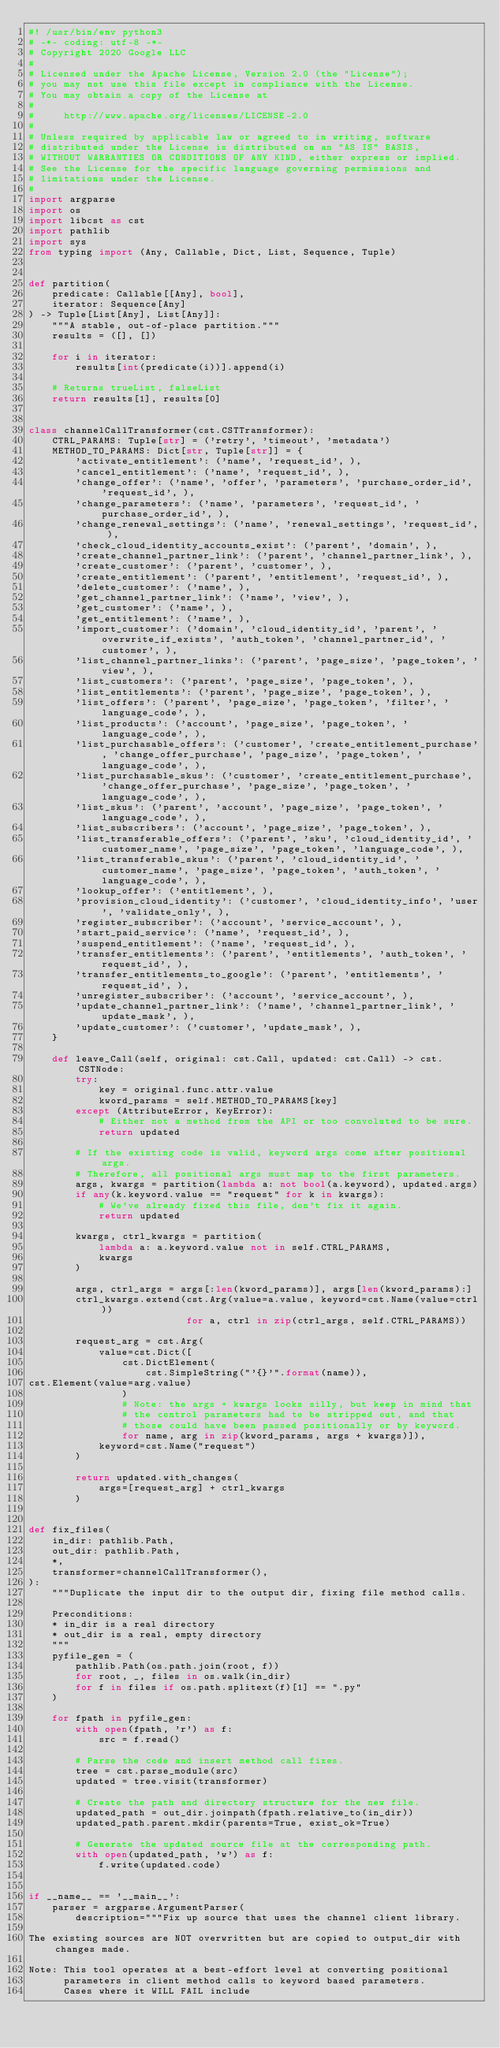<code> <loc_0><loc_0><loc_500><loc_500><_Python_>#! /usr/bin/env python3
# -*- coding: utf-8 -*-
# Copyright 2020 Google LLC
#
# Licensed under the Apache License, Version 2.0 (the "License");
# you may not use this file except in compliance with the License.
# You may obtain a copy of the License at
#
#     http://www.apache.org/licenses/LICENSE-2.0
#
# Unless required by applicable law or agreed to in writing, software
# distributed under the License is distributed on an "AS IS" BASIS,
# WITHOUT WARRANTIES OR CONDITIONS OF ANY KIND, either express or implied.
# See the License for the specific language governing permissions and
# limitations under the License.
#
import argparse
import os
import libcst as cst
import pathlib
import sys
from typing import (Any, Callable, Dict, List, Sequence, Tuple)


def partition(
    predicate: Callable[[Any], bool],
    iterator: Sequence[Any]
) -> Tuple[List[Any], List[Any]]:
    """A stable, out-of-place partition."""
    results = ([], [])

    for i in iterator:
        results[int(predicate(i))].append(i)

    # Returns trueList, falseList
    return results[1], results[0]


class channelCallTransformer(cst.CSTTransformer):
    CTRL_PARAMS: Tuple[str] = ('retry', 'timeout', 'metadata')
    METHOD_TO_PARAMS: Dict[str, Tuple[str]] = {
        'activate_entitlement': ('name', 'request_id', ),
        'cancel_entitlement': ('name', 'request_id', ),
        'change_offer': ('name', 'offer', 'parameters', 'purchase_order_id', 'request_id', ),
        'change_parameters': ('name', 'parameters', 'request_id', 'purchase_order_id', ),
        'change_renewal_settings': ('name', 'renewal_settings', 'request_id', ),
        'check_cloud_identity_accounts_exist': ('parent', 'domain', ),
        'create_channel_partner_link': ('parent', 'channel_partner_link', ),
        'create_customer': ('parent', 'customer', ),
        'create_entitlement': ('parent', 'entitlement', 'request_id', ),
        'delete_customer': ('name', ),
        'get_channel_partner_link': ('name', 'view', ),
        'get_customer': ('name', ),
        'get_entitlement': ('name', ),
        'import_customer': ('domain', 'cloud_identity_id', 'parent', 'overwrite_if_exists', 'auth_token', 'channel_partner_id', 'customer', ),
        'list_channel_partner_links': ('parent', 'page_size', 'page_token', 'view', ),
        'list_customers': ('parent', 'page_size', 'page_token', ),
        'list_entitlements': ('parent', 'page_size', 'page_token', ),
        'list_offers': ('parent', 'page_size', 'page_token', 'filter', 'language_code', ),
        'list_products': ('account', 'page_size', 'page_token', 'language_code', ),
        'list_purchasable_offers': ('customer', 'create_entitlement_purchase', 'change_offer_purchase', 'page_size', 'page_token', 'language_code', ),
        'list_purchasable_skus': ('customer', 'create_entitlement_purchase', 'change_offer_purchase', 'page_size', 'page_token', 'language_code', ),
        'list_skus': ('parent', 'account', 'page_size', 'page_token', 'language_code', ),
        'list_subscribers': ('account', 'page_size', 'page_token', ),
        'list_transferable_offers': ('parent', 'sku', 'cloud_identity_id', 'customer_name', 'page_size', 'page_token', 'language_code', ),
        'list_transferable_skus': ('parent', 'cloud_identity_id', 'customer_name', 'page_size', 'page_token', 'auth_token', 'language_code', ),
        'lookup_offer': ('entitlement', ),
        'provision_cloud_identity': ('customer', 'cloud_identity_info', 'user', 'validate_only', ),
        'register_subscriber': ('account', 'service_account', ),
        'start_paid_service': ('name', 'request_id', ),
        'suspend_entitlement': ('name', 'request_id', ),
        'transfer_entitlements': ('parent', 'entitlements', 'auth_token', 'request_id', ),
        'transfer_entitlements_to_google': ('parent', 'entitlements', 'request_id', ),
        'unregister_subscriber': ('account', 'service_account', ),
        'update_channel_partner_link': ('name', 'channel_partner_link', 'update_mask', ),
        'update_customer': ('customer', 'update_mask', ),
    }

    def leave_Call(self, original: cst.Call, updated: cst.Call) -> cst.CSTNode:
        try:
            key = original.func.attr.value
            kword_params = self.METHOD_TO_PARAMS[key]
        except (AttributeError, KeyError):
            # Either not a method from the API or too convoluted to be sure.
            return updated

        # If the existing code is valid, keyword args come after positional args.
        # Therefore, all positional args must map to the first parameters.
        args, kwargs = partition(lambda a: not bool(a.keyword), updated.args)
        if any(k.keyword.value == "request" for k in kwargs):
            # We've already fixed this file, don't fix it again.
            return updated

        kwargs, ctrl_kwargs = partition(
            lambda a: a.keyword.value not in self.CTRL_PARAMS,
            kwargs
        )

        args, ctrl_args = args[:len(kword_params)], args[len(kword_params):]
        ctrl_kwargs.extend(cst.Arg(value=a.value, keyword=cst.Name(value=ctrl))
                           for a, ctrl in zip(ctrl_args, self.CTRL_PARAMS))

        request_arg = cst.Arg(
            value=cst.Dict([
                cst.DictElement(
                    cst.SimpleString("'{}'".format(name)),
cst.Element(value=arg.value)
                )
                # Note: the args + kwargs looks silly, but keep in mind that
                # the control parameters had to be stripped out, and that
                # those could have been passed positionally or by keyword.
                for name, arg in zip(kword_params, args + kwargs)]),
            keyword=cst.Name("request")
        )

        return updated.with_changes(
            args=[request_arg] + ctrl_kwargs
        )


def fix_files(
    in_dir: pathlib.Path,
    out_dir: pathlib.Path,
    *,
    transformer=channelCallTransformer(),
):
    """Duplicate the input dir to the output dir, fixing file method calls.

    Preconditions:
    * in_dir is a real directory
    * out_dir is a real, empty directory
    """
    pyfile_gen = (
        pathlib.Path(os.path.join(root, f))
        for root, _, files in os.walk(in_dir)
        for f in files if os.path.splitext(f)[1] == ".py"
    )

    for fpath in pyfile_gen:
        with open(fpath, 'r') as f:
            src = f.read()

        # Parse the code and insert method call fixes.
        tree = cst.parse_module(src)
        updated = tree.visit(transformer)

        # Create the path and directory structure for the new file.
        updated_path = out_dir.joinpath(fpath.relative_to(in_dir))
        updated_path.parent.mkdir(parents=True, exist_ok=True)

        # Generate the updated source file at the corresponding path.
        with open(updated_path, 'w') as f:
            f.write(updated.code)


if __name__ == '__main__':
    parser = argparse.ArgumentParser(
        description="""Fix up source that uses the channel client library.

The existing sources are NOT overwritten but are copied to output_dir with changes made.

Note: This tool operates at a best-effort level at converting positional
      parameters in client method calls to keyword based parameters.
      Cases where it WILL FAIL include</code> 